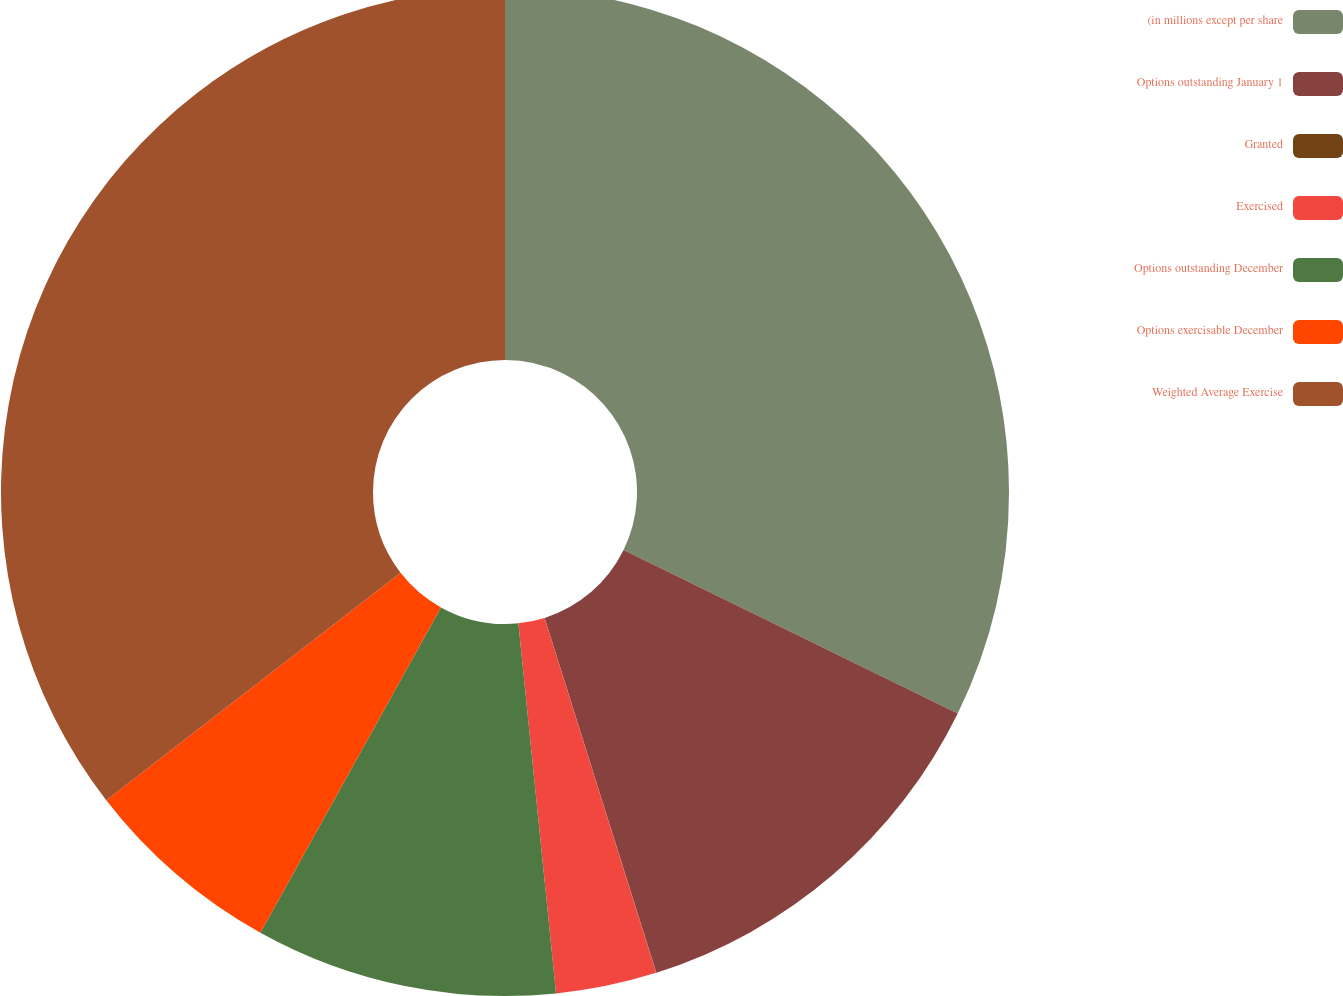Convert chart. <chart><loc_0><loc_0><loc_500><loc_500><pie_chart><fcel>(in millions except per share<fcel>Options outstanding January 1<fcel>Granted<fcel>Exercised<fcel>Options outstanding December<fcel>Options exercisable December<fcel>Weighted Average Exercise<nl><fcel>32.24%<fcel>12.9%<fcel>0.01%<fcel>3.23%<fcel>9.68%<fcel>6.46%<fcel>35.47%<nl></chart> 